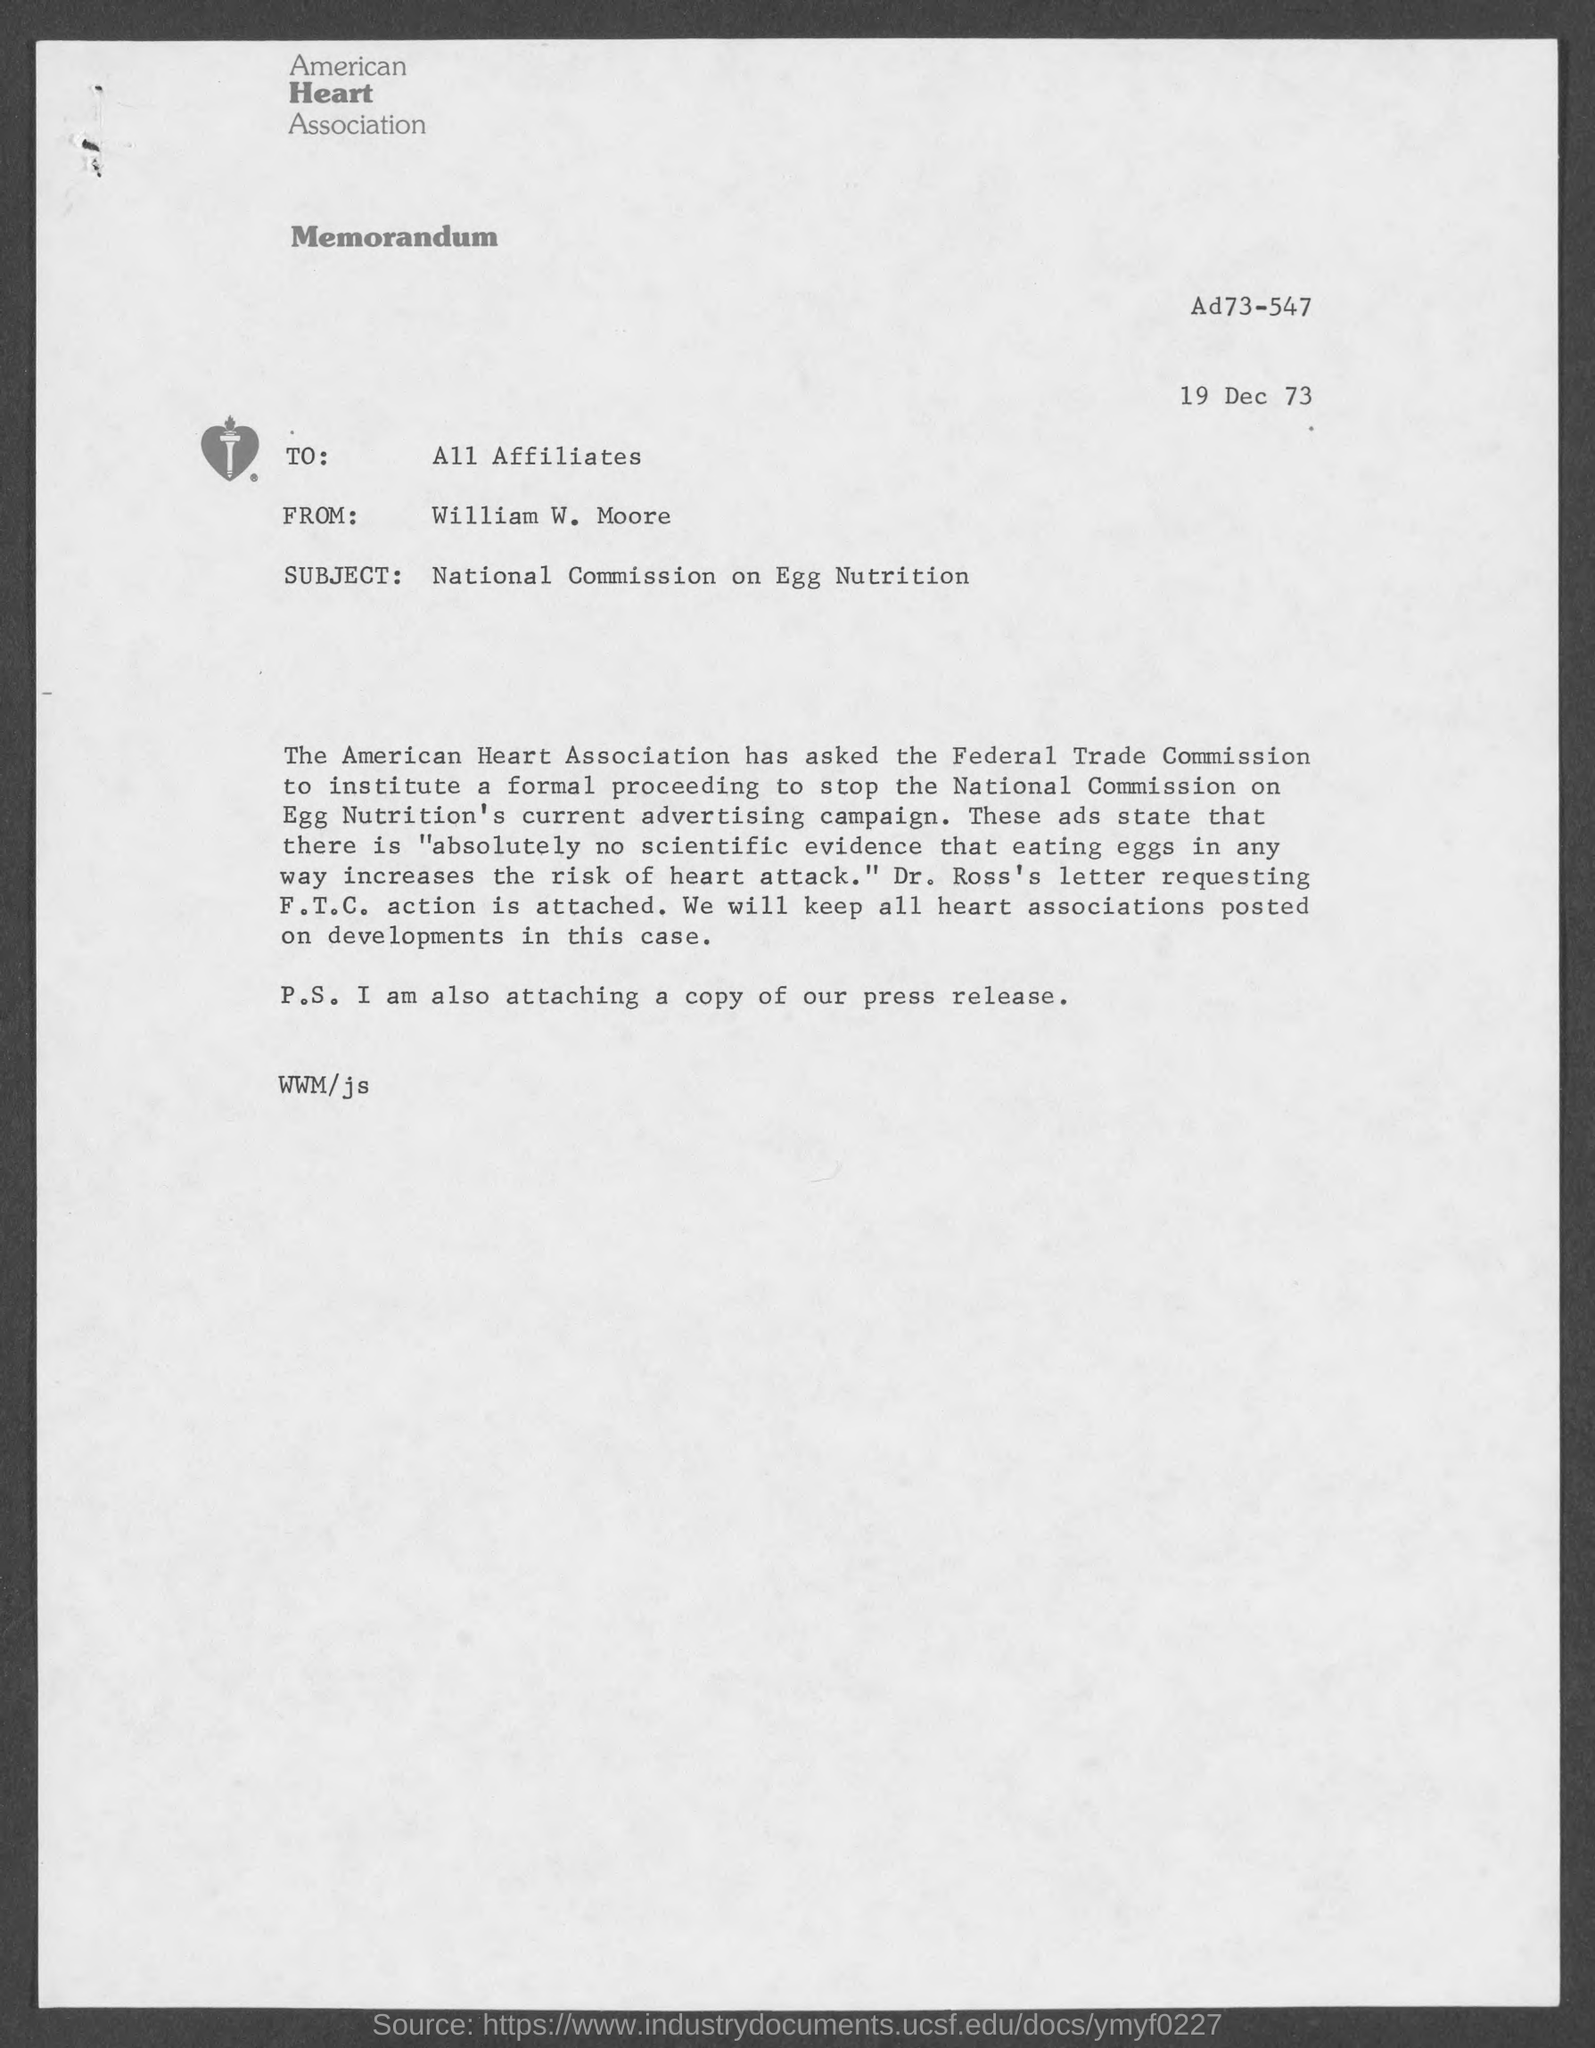Which asociation is mentioned in the letterhead?
Ensure brevity in your answer.  American heart association. What is the date mentioned in the memorandum?
Provide a short and direct response. 19 Dec 73. Who is the sender of this memorandum?
Your answer should be compact. William w. moore. To whom, the memorandum is addressed?
Provide a succinct answer. All Affiliates. What is the subject of this memorandum?
Provide a short and direct response. National commission on egg nutrition. 